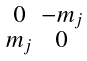Convert formula to latex. <formula><loc_0><loc_0><loc_500><loc_500>\begin{smallmatrix} 0 & - m _ { j } \\ m _ { j } & 0 \end{smallmatrix}</formula> 